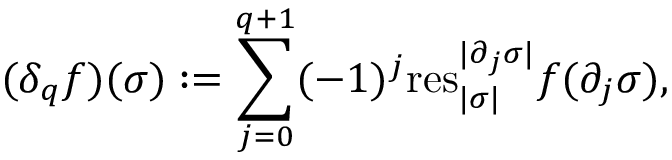Convert formula to latex. <formula><loc_0><loc_0><loc_500><loc_500>( \delta _ { q } f ) ( \sigma ) \colon = \sum _ { j = 0 } ^ { q + 1 } ( - 1 ) ^ { j } r e s _ { | \sigma | } ^ { | \partial _ { j } \sigma | } f ( \partial _ { j } \sigma ) ,</formula> 